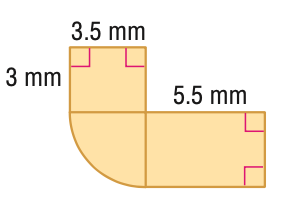Question: Find the area of the figure. Round to the nearest tenth if necessary.
Choices:
A. 39.4
B. 49.0
C. 68.2
D. 78.7
Answer with the letter. Answer: A 